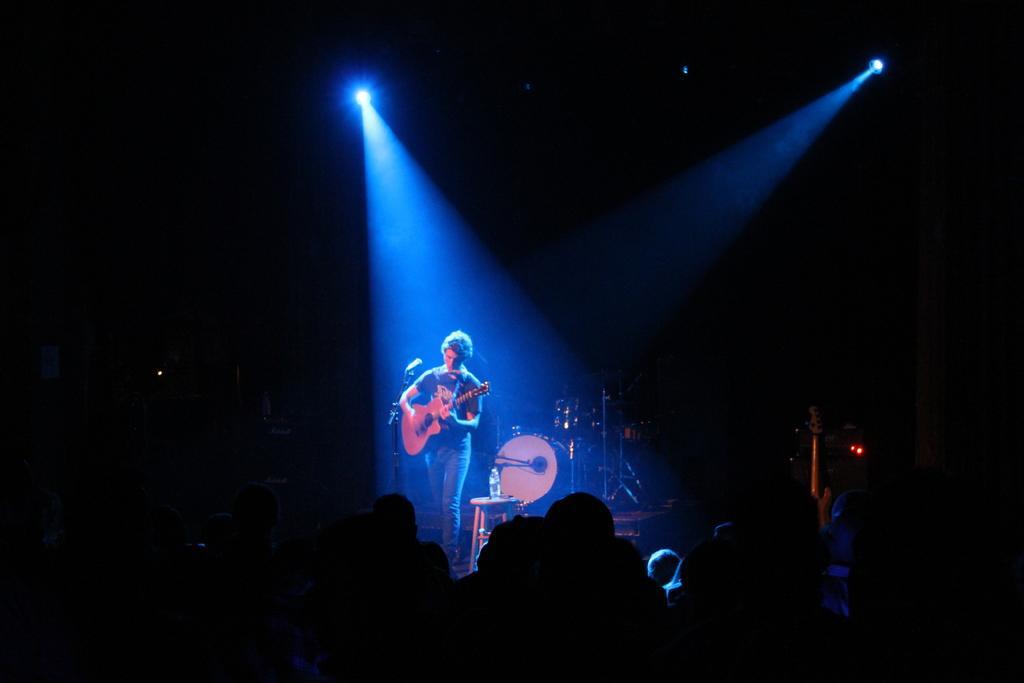Describe this image in one or two sentences. In this image we can see a few people, in front of them there is a person standing and playing a guitar, there are some strands, lights, mic, stool, water bottle and some other objects. 